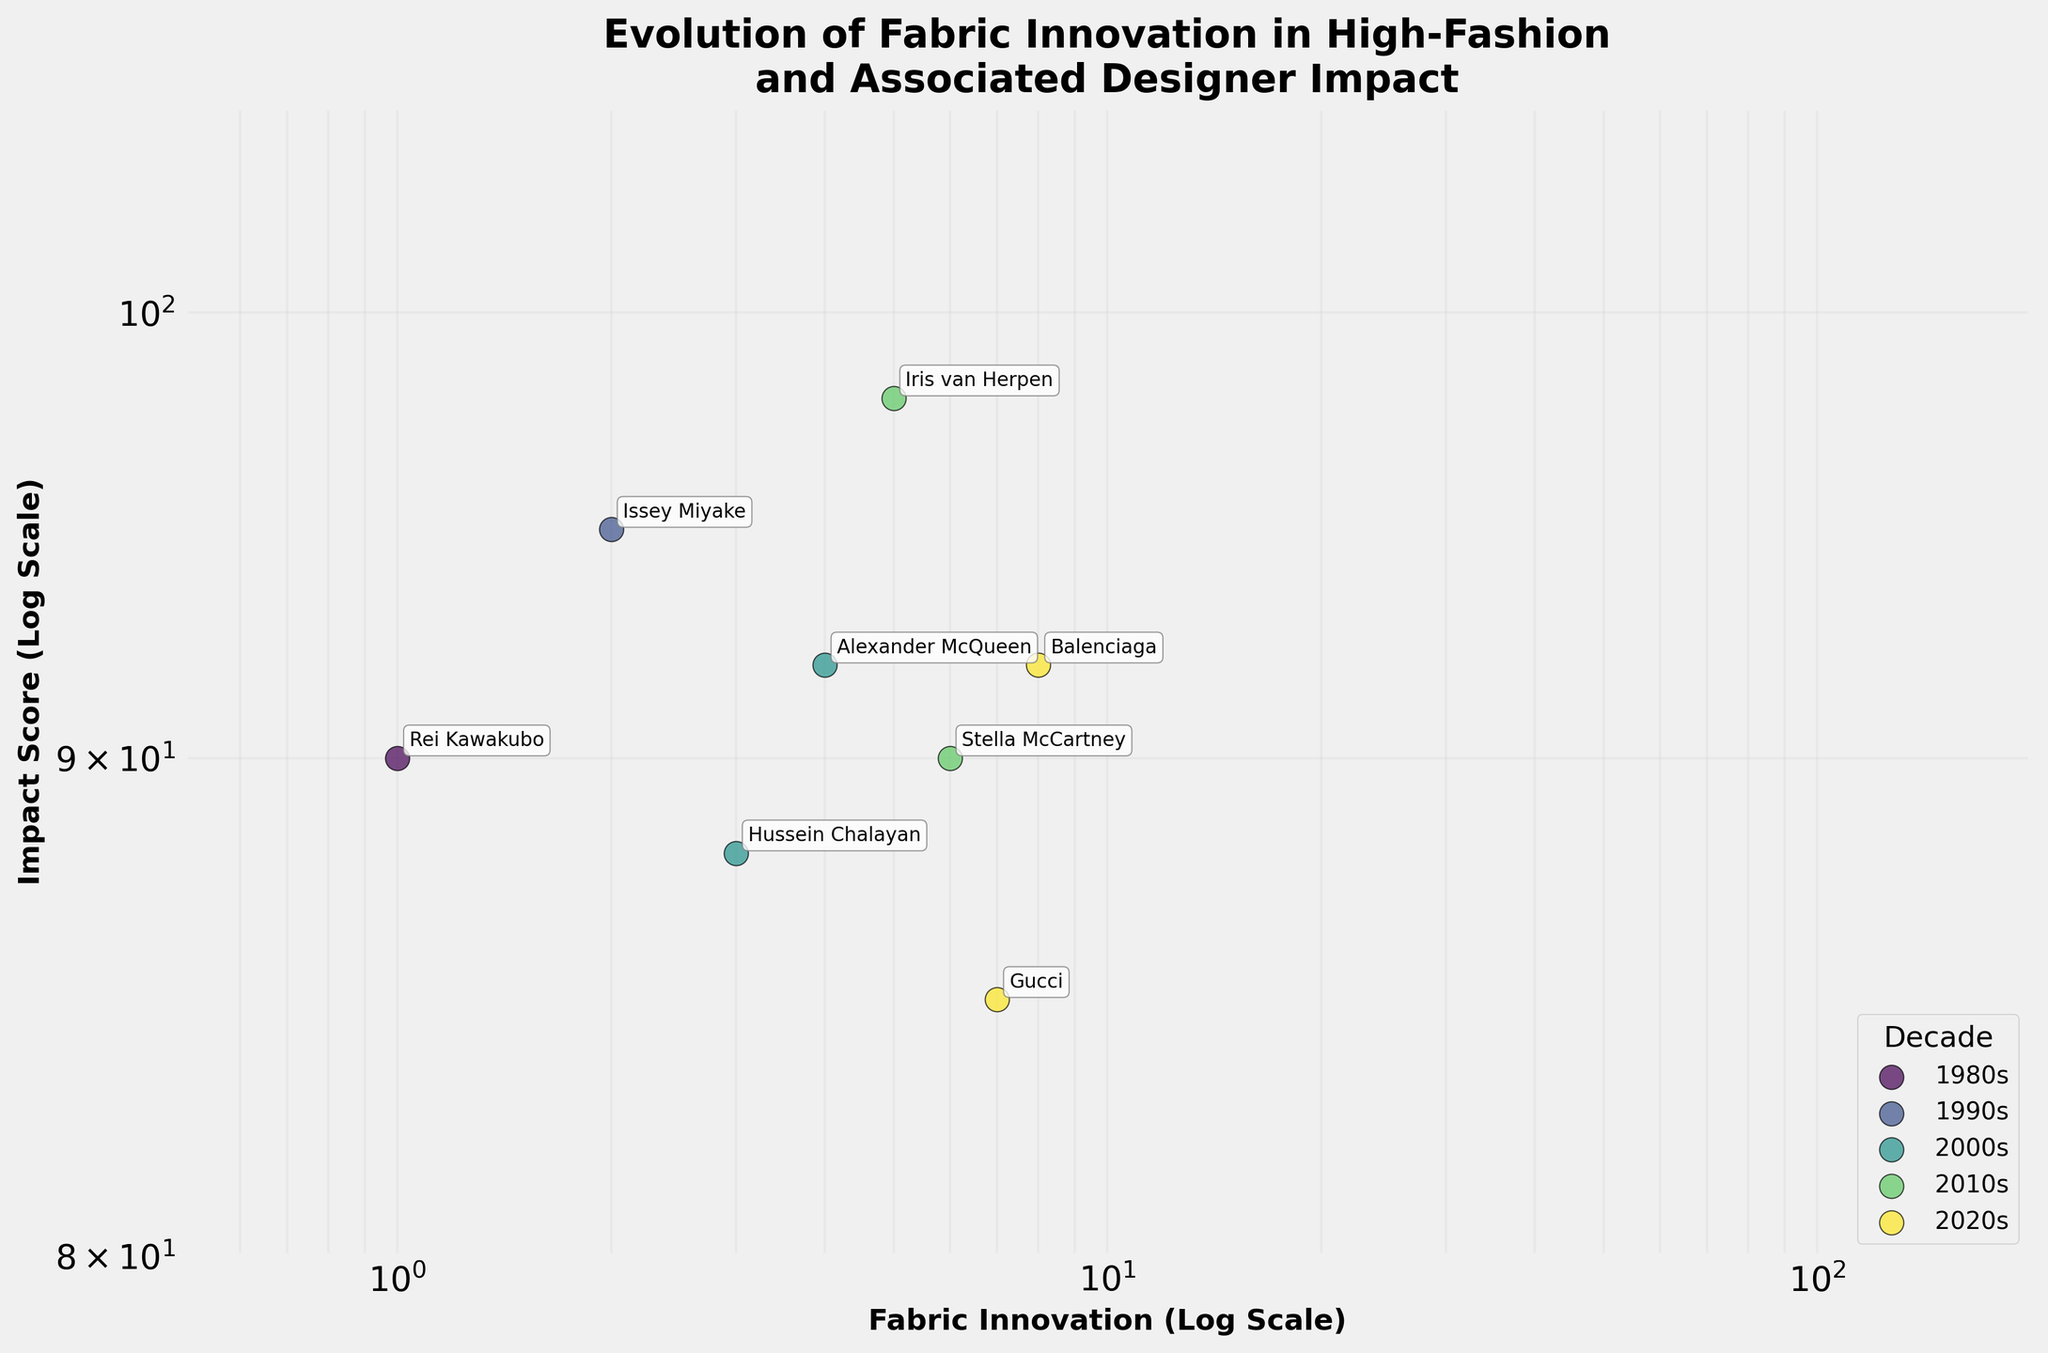what is the range of the impact score in the plot? The impact scores in the plot range from the lowest value to the highest value displayed on the y-axis. The minimum impact score is slightly above 80, and the highest is around 100.
Answer: 80-100 Which designer has the highest impact score? By checking the plot for the highest point on the y-axis and looking at the label, Iris van Herpen in the 2010s with 3D Printed Fabrics has the highest impact score.
Answer: Iris van Herpen What decade has the most data points? Count the number of unique data points (designer innovations) for each decade. The 2020s and 2010s both have two designers each, which are the maximum.
Answer: 2020s and 2010s Compare the impact scores of Alexander McQueen and Issey Miyake. Who has a higher score? Locate both designers on the plot and compare their y-axis values. Issey Miyake in the 1990s with "Pleats Please" has a higher impact score (95) compared to Alexander McQueen's "Futuristic Textiles" in the 2000s (92).
Answer: Issey Miyake What color represents the 1980s in the scatter plot? Each decade is associated with a unique color as indicated by the legend. The 1980s' color is the first one in the gradient legend.
Answer: 1980s have the first color in the legend (viridis scale) Which innovation appears at the lowest impact score, and by which designer? Find the lowest point on the y-axis and check its corresponding label. Yohji Yamamoto's Asymmetric Knits in the 1980s has the lowest impact score, around 85.
Answer: Yohji Yamamoto How many designers have innovations with impact scores above 90? Count the number of data points that are above the impact score of 90 on the y-axis. From the plot, there are six data points above 90.
Answer: Six designers Which decade shows the most diversity in fabric innovation based on the scatter plot spread? Observe the horizontal spread of data points for each decade. The 2020s have two innovations (Eco-Friendly Denim and Bioengineered Leather) that cover a wide range of x-axis values, indicating diverse fabric innovation.
Answer: 2020s Do any designers show up twice on the plot? Examine all the labels next to each data point and check for repetitions. Each designer appears only once on the plot, hence no repetitions.
Answer: No What is the x-axis label and what does the x-axis scale represent? The x-axis label describes what the horizontal axis measures and its scaling. The label is "Fabric Innovation (Log Scale)", meaning the x-axis uses a logarithmic scale to represent the fabric innovations.
Answer: Fabric Innovation (Log Scale) 